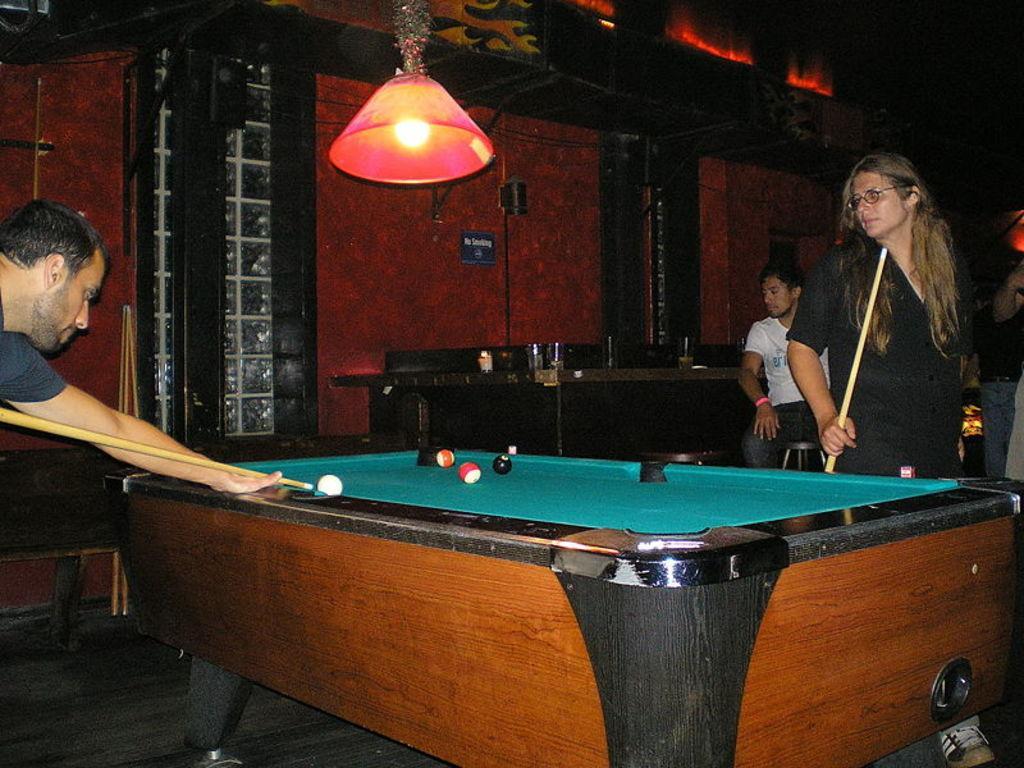How would you summarize this image in a sentence or two? There is a man and a woman playing a game on the table with the sticks, standing on opposite side of the table. There is a light above the table. In the background there is a man sitting on the stool near the table and there is a wall here. 